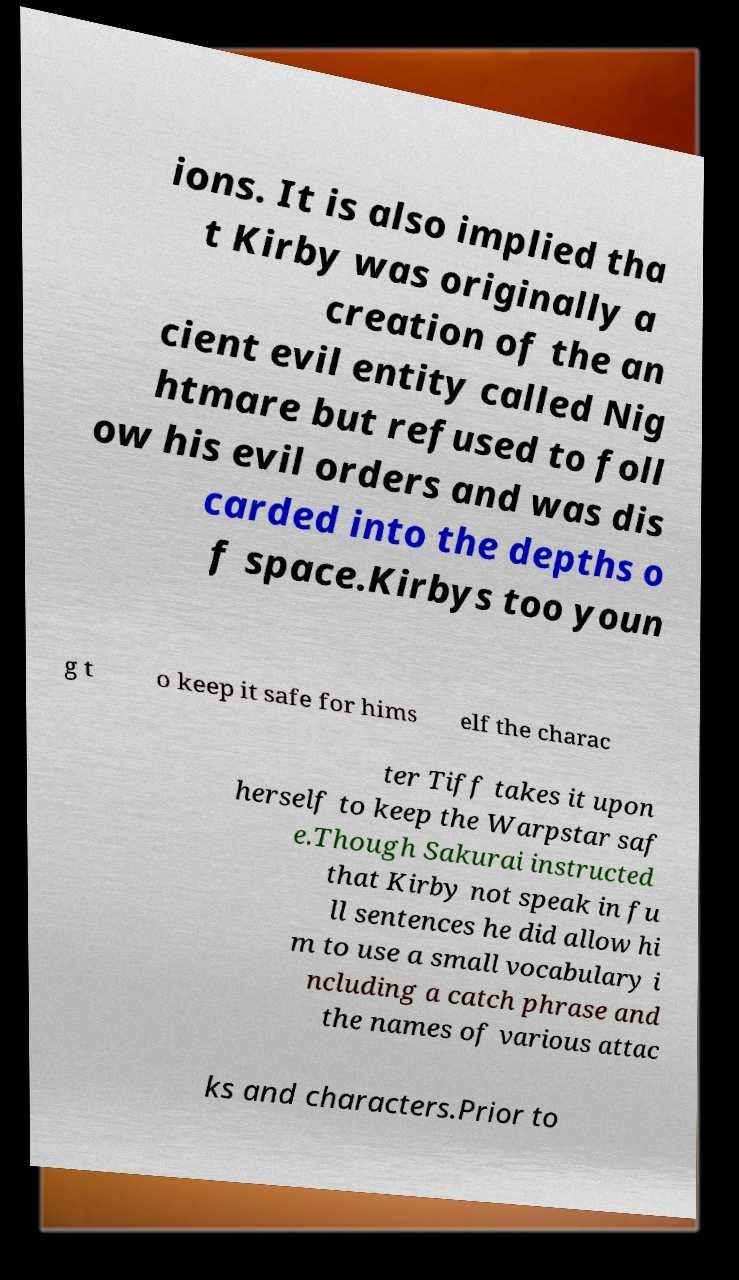For documentation purposes, I need the text within this image transcribed. Could you provide that? ions. It is also implied tha t Kirby was originally a creation of the an cient evil entity called Nig htmare but refused to foll ow his evil orders and was dis carded into the depths o f space.Kirbys too youn g t o keep it safe for hims elf the charac ter Tiff takes it upon herself to keep the Warpstar saf e.Though Sakurai instructed that Kirby not speak in fu ll sentences he did allow hi m to use a small vocabulary i ncluding a catch phrase and the names of various attac ks and characters.Prior to 